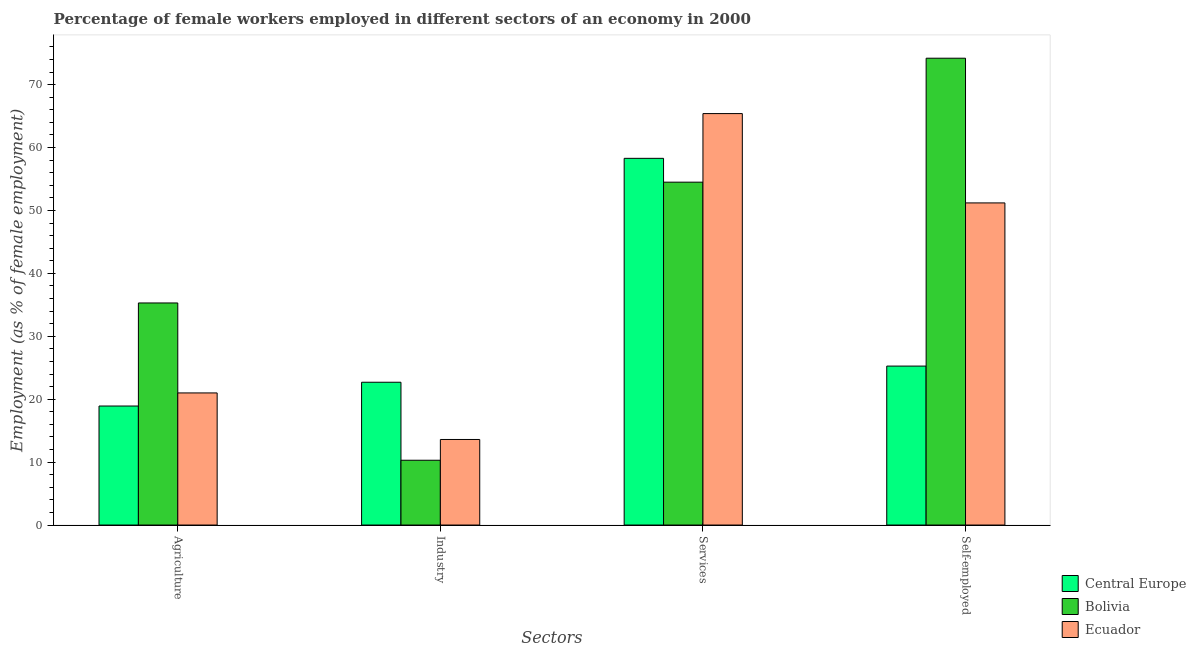How many groups of bars are there?
Your answer should be compact. 4. Are the number of bars per tick equal to the number of legend labels?
Offer a terse response. Yes. Are the number of bars on each tick of the X-axis equal?
Offer a very short reply. Yes. What is the label of the 3rd group of bars from the left?
Give a very brief answer. Services. What is the percentage of self employed female workers in Central Europe?
Your answer should be compact. 25.27. Across all countries, what is the maximum percentage of female workers in industry?
Provide a succinct answer. 22.7. Across all countries, what is the minimum percentage of female workers in industry?
Offer a very short reply. 10.3. In which country was the percentage of female workers in industry maximum?
Provide a succinct answer. Central Europe. In which country was the percentage of female workers in agriculture minimum?
Give a very brief answer. Central Europe. What is the total percentage of female workers in industry in the graph?
Provide a succinct answer. 46.6. What is the difference between the percentage of female workers in industry in Bolivia and that in Ecuador?
Make the answer very short. -3.3. What is the difference between the percentage of female workers in industry in Central Europe and the percentage of female workers in services in Ecuador?
Make the answer very short. -42.7. What is the average percentage of female workers in agriculture per country?
Your answer should be compact. 25.07. What is the difference between the percentage of female workers in services and percentage of female workers in agriculture in Ecuador?
Ensure brevity in your answer.  44.4. What is the ratio of the percentage of female workers in industry in Ecuador to that in Bolivia?
Provide a succinct answer. 1.32. What is the difference between the highest and the second highest percentage of female workers in agriculture?
Provide a short and direct response. 14.3. What is the difference between the highest and the lowest percentage of female workers in industry?
Your answer should be very brief. 12.4. Is it the case that in every country, the sum of the percentage of female workers in services and percentage of female workers in industry is greater than the sum of percentage of female workers in agriculture and percentage of self employed female workers?
Give a very brief answer. No. What does the 3rd bar from the left in Industry represents?
Offer a terse response. Ecuador. What does the 3rd bar from the right in Services represents?
Your response must be concise. Central Europe. How many bars are there?
Your answer should be compact. 12. How many countries are there in the graph?
Give a very brief answer. 3. What is the difference between two consecutive major ticks on the Y-axis?
Provide a succinct answer. 10. How many legend labels are there?
Provide a succinct answer. 3. What is the title of the graph?
Your response must be concise. Percentage of female workers employed in different sectors of an economy in 2000. Does "Gabon" appear as one of the legend labels in the graph?
Offer a very short reply. No. What is the label or title of the X-axis?
Make the answer very short. Sectors. What is the label or title of the Y-axis?
Offer a terse response. Employment (as % of female employment). What is the Employment (as % of female employment) of Central Europe in Agriculture?
Make the answer very short. 18.92. What is the Employment (as % of female employment) in Bolivia in Agriculture?
Make the answer very short. 35.3. What is the Employment (as % of female employment) in Ecuador in Agriculture?
Give a very brief answer. 21. What is the Employment (as % of female employment) in Central Europe in Industry?
Offer a very short reply. 22.7. What is the Employment (as % of female employment) of Bolivia in Industry?
Your answer should be very brief. 10.3. What is the Employment (as % of female employment) in Ecuador in Industry?
Ensure brevity in your answer.  13.6. What is the Employment (as % of female employment) of Central Europe in Services?
Give a very brief answer. 58.29. What is the Employment (as % of female employment) of Bolivia in Services?
Provide a succinct answer. 54.5. What is the Employment (as % of female employment) in Ecuador in Services?
Provide a succinct answer. 65.4. What is the Employment (as % of female employment) in Central Europe in Self-employed?
Make the answer very short. 25.27. What is the Employment (as % of female employment) of Bolivia in Self-employed?
Provide a short and direct response. 74.2. What is the Employment (as % of female employment) of Ecuador in Self-employed?
Your answer should be very brief. 51.2. Across all Sectors, what is the maximum Employment (as % of female employment) in Central Europe?
Your answer should be compact. 58.29. Across all Sectors, what is the maximum Employment (as % of female employment) in Bolivia?
Make the answer very short. 74.2. Across all Sectors, what is the maximum Employment (as % of female employment) in Ecuador?
Provide a short and direct response. 65.4. Across all Sectors, what is the minimum Employment (as % of female employment) of Central Europe?
Provide a succinct answer. 18.92. Across all Sectors, what is the minimum Employment (as % of female employment) in Bolivia?
Your answer should be compact. 10.3. Across all Sectors, what is the minimum Employment (as % of female employment) in Ecuador?
Your response must be concise. 13.6. What is the total Employment (as % of female employment) of Central Europe in the graph?
Provide a short and direct response. 125.17. What is the total Employment (as % of female employment) in Bolivia in the graph?
Your answer should be compact. 174.3. What is the total Employment (as % of female employment) of Ecuador in the graph?
Your answer should be very brief. 151.2. What is the difference between the Employment (as % of female employment) in Central Europe in Agriculture and that in Industry?
Your response must be concise. -3.78. What is the difference between the Employment (as % of female employment) of Ecuador in Agriculture and that in Industry?
Offer a very short reply. 7.4. What is the difference between the Employment (as % of female employment) in Central Europe in Agriculture and that in Services?
Make the answer very short. -39.37. What is the difference between the Employment (as % of female employment) in Bolivia in Agriculture and that in Services?
Provide a short and direct response. -19.2. What is the difference between the Employment (as % of female employment) of Ecuador in Agriculture and that in Services?
Your answer should be very brief. -44.4. What is the difference between the Employment (as % of female employment) in Central Europe in Agriculture and that in Self-employed?
Provide a short and direct response. -6.35. What is the difference between the Employment (as % of female employment) of Bolivia in Agriculture and that in Self-employed?
Ensure brevity in your answer.  -38.9. What is the difference between the Employment (as % of female employment) in Ecuador in Agriculture and that in Self-employed?
Offer a very short reply. -30.2. What is the difference between the Employment (as % of female employment) of Central Europe in Industry and that in Services?
Keep it short and to the point. -35.59. What is the difference between the Employment (as % of female employment) of Bolivia in Industry and that in Services?
Your answer should be very brief. -44.2. What is the difference between the Employment (as % of female employment) of Ecuador in Industry and that in Services?
Ensure brevity in your answer.  -51.8. What is the difference between the Employment (as % of female employment) of Central Europe in Industry and that in Self-employed?
Provide a succinct answer. -2.57. What is the difference between the Employment (as % of female employment) in Bolivia in Industry and that in Self-employed?
Keep it short and to the point. -63.9. What is the difference between the Employment (as % of female employment) of Ecuador in Industry and that in Self-employed?
Give a very brief answer. -37.6. What is the difference between the Employment (as % of female employment) of Central Europe in Services and that in Self-employed?
Provide a short and direct response. 33.02. What is the difference between the Employment (as % of female employment) of Bolivia in Services and that in Self-employed?
Ensure brevity in your answer.  -19.7. What is the difference between the Employment (as % of female employment) of Ecuador in Services and that in Self-employed?
Your answer should be very brief. 14.2. What is the difference between the Employment (as % of female employment) in Central Europe in Agriculture and the Employment (as % of female employment) in Bolivia in Industry?
Ensure brevity in your answer.  8.62. What is the difference between the Employment (as % of female employment) in Central Europe in Agriculture and the Employment (as % of female employment) in Ecuador in Industry?
Your answer should be compact. 5.32. What is the difference between the Employment (as % of female employment) of Bolivia in Agriculture and the Employment (as % of female employment) of Ecuador in Industry?
Keep it short and to the point. 21.7. What is the difference between the Employment (as % of female employment) of Central Europe in Agriculture and the Employment (as % of female employment) of Bolivia in Services?
Your answer should be compact. -35.58. What is the difference between the Employment (as % of female employment) of Central Europe in Agriculture and the Employment (as % of female employment) of Ecuador in Services?
Provide a short and direct response. -46.48. What is the difference between the Employment (as % of female employment) of Bolivia in Agriculture and the Employment (as % of female employment) of Ecuador in Services?
Ensure brevity in your answer.  -30.1. What is the difference between the Employment (as % of female employment) in Central Europe in Agriculture and the Employment (as % of female employment) in Bolivia in Self-employed?
Your response must be concise. -55.28. What is the difference between the Employment (as % of female employment) of Central Europe in Agriculture and the Employment (as % of female employment) of Ecuador in Self-employed?
Provide a succinct answer. -32.28. What is the difference between the Employment (as % of female employment) of Bolivia in Agriculture and the Employment (as % of female employment) of Ecuador in Self-employed?
Offer a very short reply. -15.9. What is the difference between the Employment (as % of female employment) in Central Europe in Industry and the Employment (as % of female employment) in Bolivia in Services?
Your answer should be compact. -31.8. What is the difference between the Employment (as % of female employment) in Central Europe in Industry and the Employment (as % of female employment) in Ecuador in Services?
Provide a succinct answer. -42.7. What is the difference between the Employment (as % of female employment) of Bolivia in Industry and the Employment (as % of female employment) of Ecuador in Services?
Make the answer very short. -55.1. What is the difference between the Employment (as % of female employment) in Central Europe in Industry and the Employment (as % of female employment) in Bolivia in Self-employed?
Give a very brief answer. -51.5. What is the difference between the Employment (as % of female employment) of Central Europe in Industry and the Employment (as % of female employment) of Ecuador in Self-employed?
Give a very brief answer. -28.5. What is the difference between the Employment (as % of female employment) of Bolivia in Industry and the Employment (as % of female employment) of Ecuador in Self-employed?
Your answer should be very brief. -40.9. What is the difference between the Employment (as % of female employment) of Central Europe in Services and the Employment (as % of female employment) of Bolivia in Self-employed?
Make the answer very short. -15.91. What is the difference between the Employment (as % of female employment) of Central Europe in Services and the Employment (as % of female employment) of Ecuador in Self-employed?
Your response must be concise. 7.09. What is the average Employment (as % of female employment) in Central Europe per Sectors?
Ensure brevity in your answer.  31.29. What is the average Employment (as % of female employment) in Bolivia per Sectors?
Provide a succinct answer. 43.58. What is the average Employment (as % of female employment) of Ecuador per Sectors?
Offer a terse response. 37.8. What is the difference between the Employment (as % of female employment) in Central Europe and Employment (as % of female employment) in Bolivia in Agriculture?
Your answer should be very brief. -16.38. What is the difference between the Employment (as % of female employment) in Central Europe and Employment (as % of female employment) in Ecuador in Agriculture?
Ensure brevity in your answer.  -2.08. What is the difference between the Employment (as % of female employment) in Central Europe and Employment (as % of female employment) in Bolivia in Industry?
Offer a terse response. 12.4. What is the difference between the Employment (as % of female employment) in Central Europe and Employment (as % of female employment) in Ecuador in Industry?
Your answer should be compact. 9.1. What is the difference between the Employment (as % of female employment) in Bolivia and Employment (as % of female employment) in Ecuador in Industry?
Offer a terse response. -3.3. What is the difference between the Employment (as % of female employment) of Central Europe and Employment (as % of female employment) of Bolivia in Services?
Make the answer very short. 3.79. What is the difference between the Employment (as % of female employment) of Central Europe and Employment (as % of female employment) of Ecuador in Services?
Keep it short and to the point. -7.11. What is the difference between the Employment (as % of female employment) of Central Europe and Employment (as % of female employment) of Bolivia in Self-employed?
Offer a very short reply. -48.93. What is the difference between the Employment (as % of female employment) of Central Europe and Employment (as % of female employment) of Ecuador in Self-employed?
Keep it short and to the point. -25.93. What is the ratio of the Employment (as % of female employment) of Central Europe in Agriculture to that in Industry?
Give a very brief answer. 0.83. What is the ratio of the Employment (as % of female employment) in Bolivia in Agriculture to that in Industry?
Offer a very short reply. 3.43. What is the ratio of the Employment (as % of female employment) of Ecuador in Agriculture to that in Industry?
Your answer should be very brief. 1.54. What is the ratio of the Employment (as % of female employment) in Central Europe in Agriculture to that in Services?
Give a very brief answer. 0.32. What is the ratio of the Employment (as % of female employment) in Bolivia in Agriculture to that in Services?
Ensure brevity in your answer.  0.65. What is the ratio of the Employment (as % of female employment) of Ecuador in Agriculture to that in Services?
Offer a terse response. 0.32. What is the ratio of the Employment (as % of female employment) of Central Europe in Agriculture to that in Self-employed?
Your answer should be compact. 0.75. What is the ratio of the Employment (as % of female employment) in Bolivia in Agriculture to that in Self-employed?
Keep it short and to the point. 0.48. What is the ratio of the Employment (as % of female employment) of Ecuador in Agriculture to that in Self-employed?
Your answer should be very brief. 0.41. What is the ratio of the Employment (as % of female employment) in Central Europe in Industry to that in Services?
Your answer should be very brief. 0.39. What is the ratio of the Employment (as % of female employment) of Bolivia in Industry to that in Services?
Ensure brevity in your answer.  0.19. What is the ratio of the Employment (as % of female employment) in Ecuador in Industry to that in Services?
Make the answer very short. 0.21. What is the ratio of the Employment (as % of female employment) in Central Europe in Industry to that in Self-employed?
Provide a short and direct response. 0.9. What is the ratio of the Employment (as % of female employment) of Bolivia in Industry to that in Self-employed?
Your answer should be very brief. 0.14. What is the ratio of the Employment (as % of female employment) in Ecuador in Industry to that in Self-employed?
Your answer should be very brief. 0.27. What is the ratio of the Employment (as % of female employment) in Central Europe in Services to that in Self-employed?
Provide a short and direct response. 2.31. What is the ratio of the Employment (as % of female employment) of Bolivia in Services to that in Self-employed?
Your response must be concise. 0.73. What is the ratio of the Employment (as % of female employment) of Ecuador in Services to that in Self-employed?
Ensure brevity in your answer.  1.28. What is the difference between the highest and the second highest Employment (as % of female employment) of Central Europe?
Your answer should be very brief. 33.02. What is the difference between the highest and the lowest Employment (as % of female employment) of Central Europe?
Provide a short and direct response. 39.37. What is the difference between the highest and the lowest Employment (as % of female employment) in Bolivia?
Keep it short and to the point. 63.9. What is the difference between the highest and the lowest Employment (as % of female employment) of Ecuador?
Offer a very short reply. 51.8. 